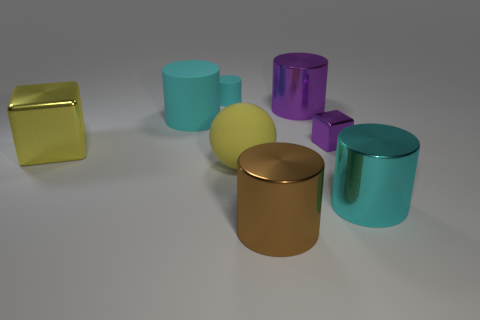There is a small cube; is it the same color as the big shiny cylinder that is behind the matte ball?
Give a very brief answer. Yes. The brown metallic object has what shape?
Offer a terse response. Cylinder. There is a cube right of the large cyan thing that is to the left of the tiny cyan matte thing; what is its size?
Ensure brevity in your answer.  Small. Is the number of small purple metallic blocks that are to the left of the brown metal object the same as the number of large purple objects that are to the left of the matte sphere?
Ensure brevity in your answer.  Yes. What is the big cylinder that is in front of the large purple metal cylinder and behind the tiny purple metal object made of?
Ensure brevity in your answer.  Rubber. Is the size of the brown metal cylinder the same as the block that is to the right of the large brown cylinder?
Provide a succinct answer. No. How many other things are there of the same color as the small shiny block?
Keep it short and to the point. 1. Are there more tiny cubes behind the yellow rubber object than large red metal spheres?
Provide a succinct answer. Yes. The metal object in front of the large metal cylinder that is on the right side of the tiny object that is on the right side of the big ball is what color?
Keep it short and to the point. Brown. Is the material of the large cube the same as the large purple object?
Offer a terse response. Yes. 